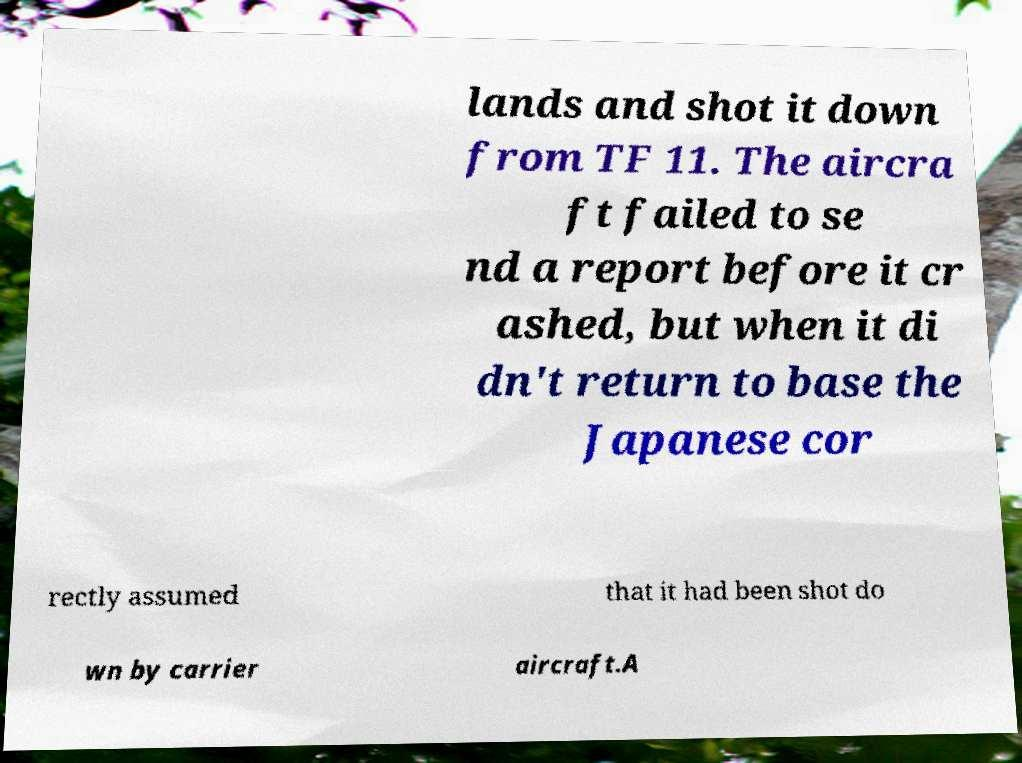Can you read and provide the text displayed in the image?This photo seems to have some interesting text. Can you extract and type it out for me? lands and shot it down from TF 11. The aircra ft failed to se nd a report before it cr ashed, but when it di dn't return to base the Japanese cor rectly assumed that it had been shot do wn by carrier aircraft.A 